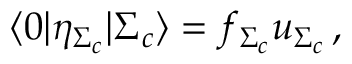Convert formula to latex. <formula><loc_0><loc_0><loc_500><loc_500>\langle 0 | \eta _ { \Sigma _ { c } } | \Sigma _ { c } \rangle = f _ { \Sigma _ { c } } u _ { \Sigma _ { c } } \, ,</formula> 